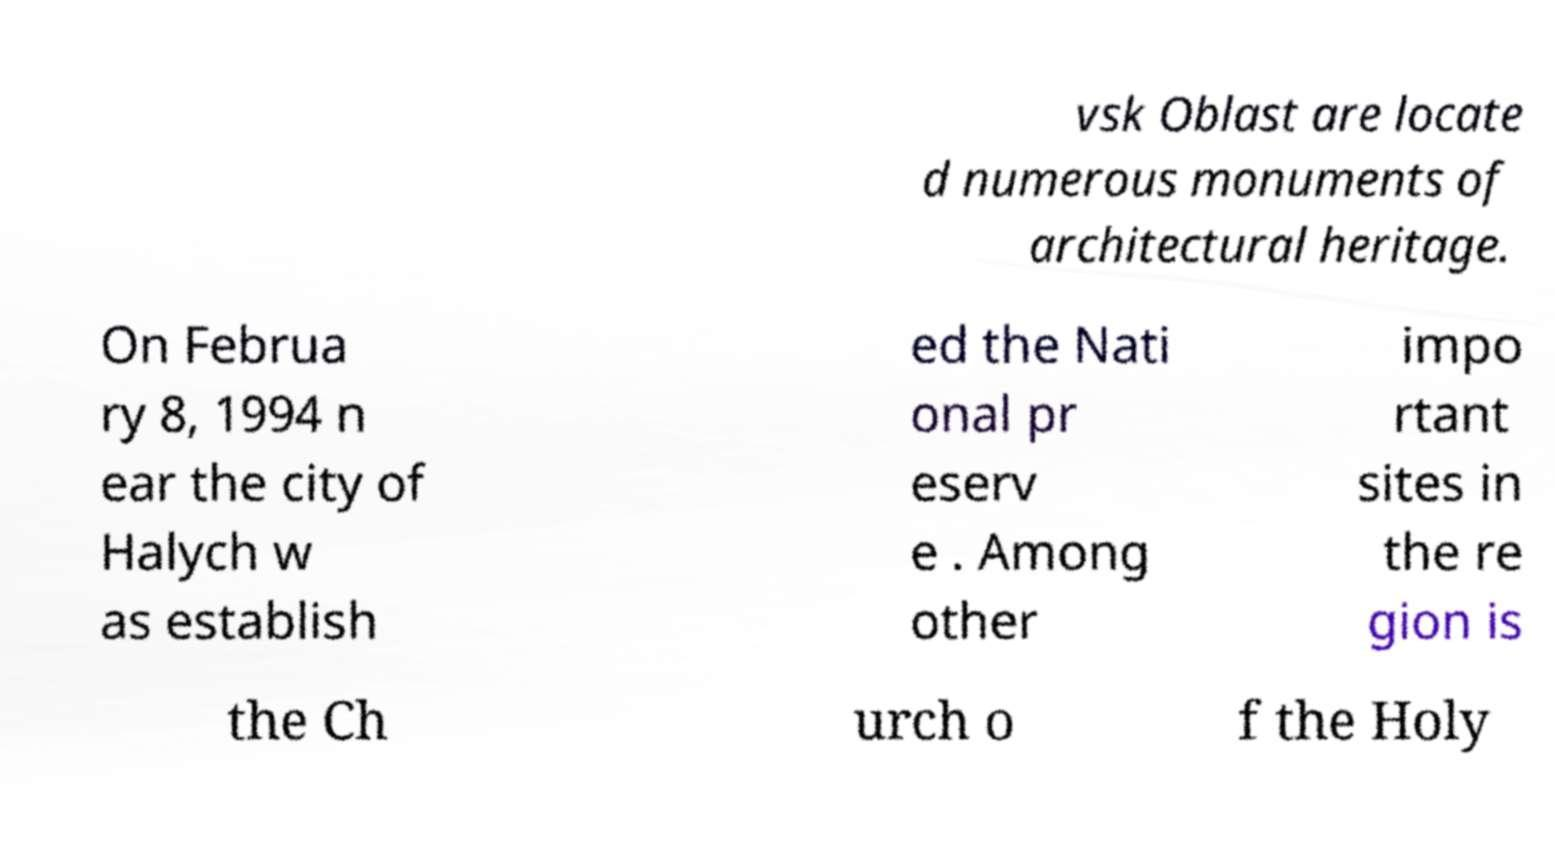There's text embedded in this image that I need extracted. Can you transcribe it verbatim? vsk Oblast are locate d numerous monuments of architectural heritage. On Februa ry 8, 1994 n ear the city of Halych w as establish ed the Nati onal pr eserv e . Among other impo rtant sites in the re gion is the Ch urch o f the Holy 